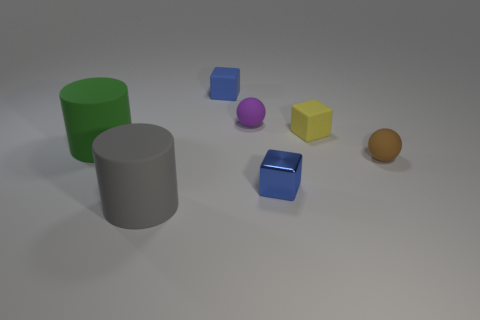Subtract all yellow blocks. How many blocks are left? 2 Subtract all blue cubes. How many cubes are left? 1 Subtract 0 red cylinders. How many objects are left? 7 Subtract all spheres. How many objects are left? 5 Subtract 2 balls. How many balls are left? 0 Subtract all gray cylinders. Subtract all brown cubes. How many cylinders are left? 1 Subtract all cyan blocks. How many green cylinders are left? 1 Subtract all purple blocks. Subtract all small brown things. How many objects are left? 6 Add 7 blue metallic things. How many blue metallic things are left? 8 Add 7 yellow balls. How many yellow balls exist? 7 